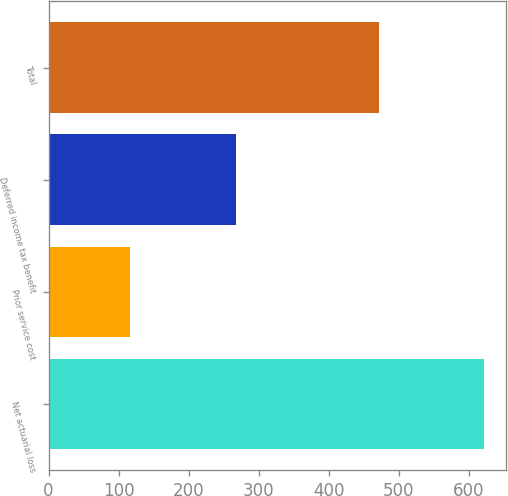Convert chart to OTSL. <chart><loc_0><loc_0><loc_500><loc_500><bar_chart><fcel>Net actuarial loss<fcel>Prior service cost<fcel>Deferred income tax benefit<fcel>Total<nl><fcel>622<fcel>116<fcel>267<fcel>471<nl></chart> 